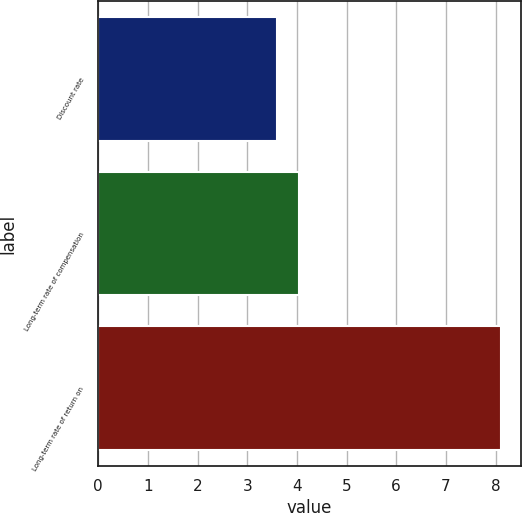Convert chart. <chart><loc_0><loc_0><loc_500><loc_500><bar_chart><fcel>Discount rate<fcel>Long-term rate of compensation<fcel>Long-term rate of return on<nl><fcel>3.6<fcel>4.05<fcel>8.1<nl></chart> 